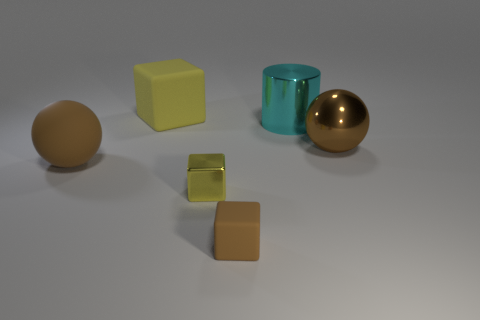Subtract all shiny blocks. How many blocks are left? 2 Add 1 brown matte cubes. How many objects exist? 7 Subtract all yellow cubes. How many cubes are left? 1 Subtract all cylinders. How many objects are left? 5 Subtract 2 spheres. How many spheres are left? 0 Subtract all brown cubes. Subtract all purple cylinders. How many cubes are left? 2 Subtract all red spheres. How many yellow cubes are left? 2 Subtract all big brown metallic objects. Subtract all big blue spheres. How many objects are left? 5 Add 5 rubber blocks. How many rubber blocks are left? 7 Add 5 tiny purple balls. How many tiny purple balls exist? 5 